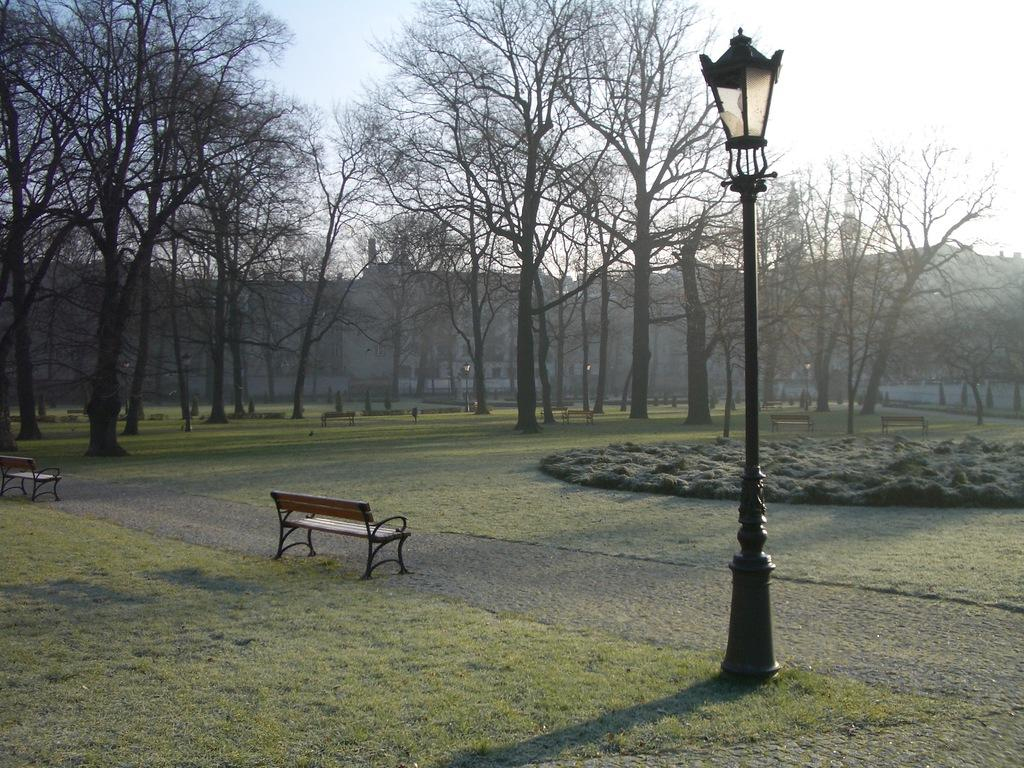What type of seating is located in the center of the image? There are benches in the center of the image. What can be seen on the right side of the image? There is a pole on the right side of the image. What is visible in the background of the image? There are trees, buildings, and the sky visible in the background of the image. How does the disgust manifest itself in the image? There is no indication of disgust in the image; it features benches, a pole, trees, buildings, and the sky. Can you describe the bite marks on the benches in the image? There are no bite marks visible on the benches in the image. 